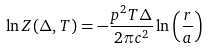Convert formula to latex. <formula><loc_0><loc_0><loc_500><loc_500>\ln Z ( \Delta , T ) = - \frac { p ^ { 2 } T \Delta } { 2 \pi c ^ { 2 } } \ln \left ( \frac { r } { a } \right )</formula> 